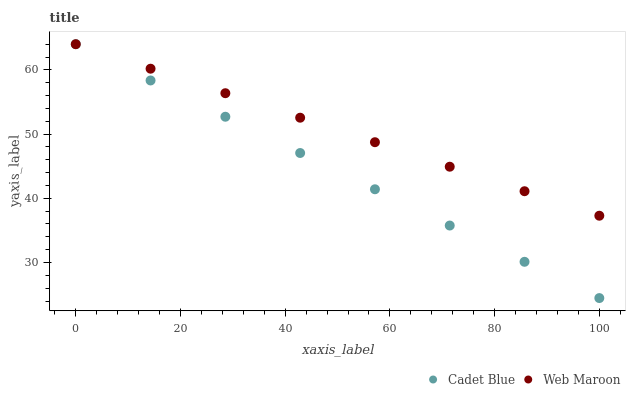Does Cadet Blue have the minimum area under the curve?
Answer yes or no. Yes. Does Web Maroon have the maximum area under the curve?
Answer yes or no. Yes. Does Web Maroon have the minimum area under the curve?
Answer yes or no. No. Is Web Maroon the smoothest?
Answer yes or no. Yes. Is Cadet Blue the roughest?
Answer yes or no. Yes. Is Web Maroon the roughest?
Answer yes or no. No. Does Cadet Blue have the lowest value?
Answer yes or no. Yes. Does Web Maroon have the lowest value?
Answer yes or no. No. Does Web Maroon have the highest value?
Answer yes or no. Yes. Does Cadet Blue intersect Web Maroon?
Answer yes or no. Yes. Is Cadet Blue less than Web Maroon?
Answer yes or no. No. Is Cadet Blue greater than Web Maroon?
Answer yes or no. No. 